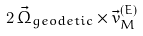Convert formula to latex. <formula><loc_0><loc_0><loc_500><loc_500>2 \, { \vec { \Omega } } _ { g e o d e t i c } \times \vec { v } ^ { ( E ) } _ { M }</formula> 